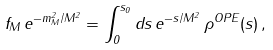<formula> <loc_0><loc_0><loc_500><loc_500>f _ { M } \, e ^ { - m _ { M } ^ { 2 } / M ^ { 2 } } = \int ^ { s _ { 0 } } _ { 0 } d s \, e ^ { - s / M ^ { 2 } } \, \rho ^ { O P E } ( s ) \, ,</formula> 